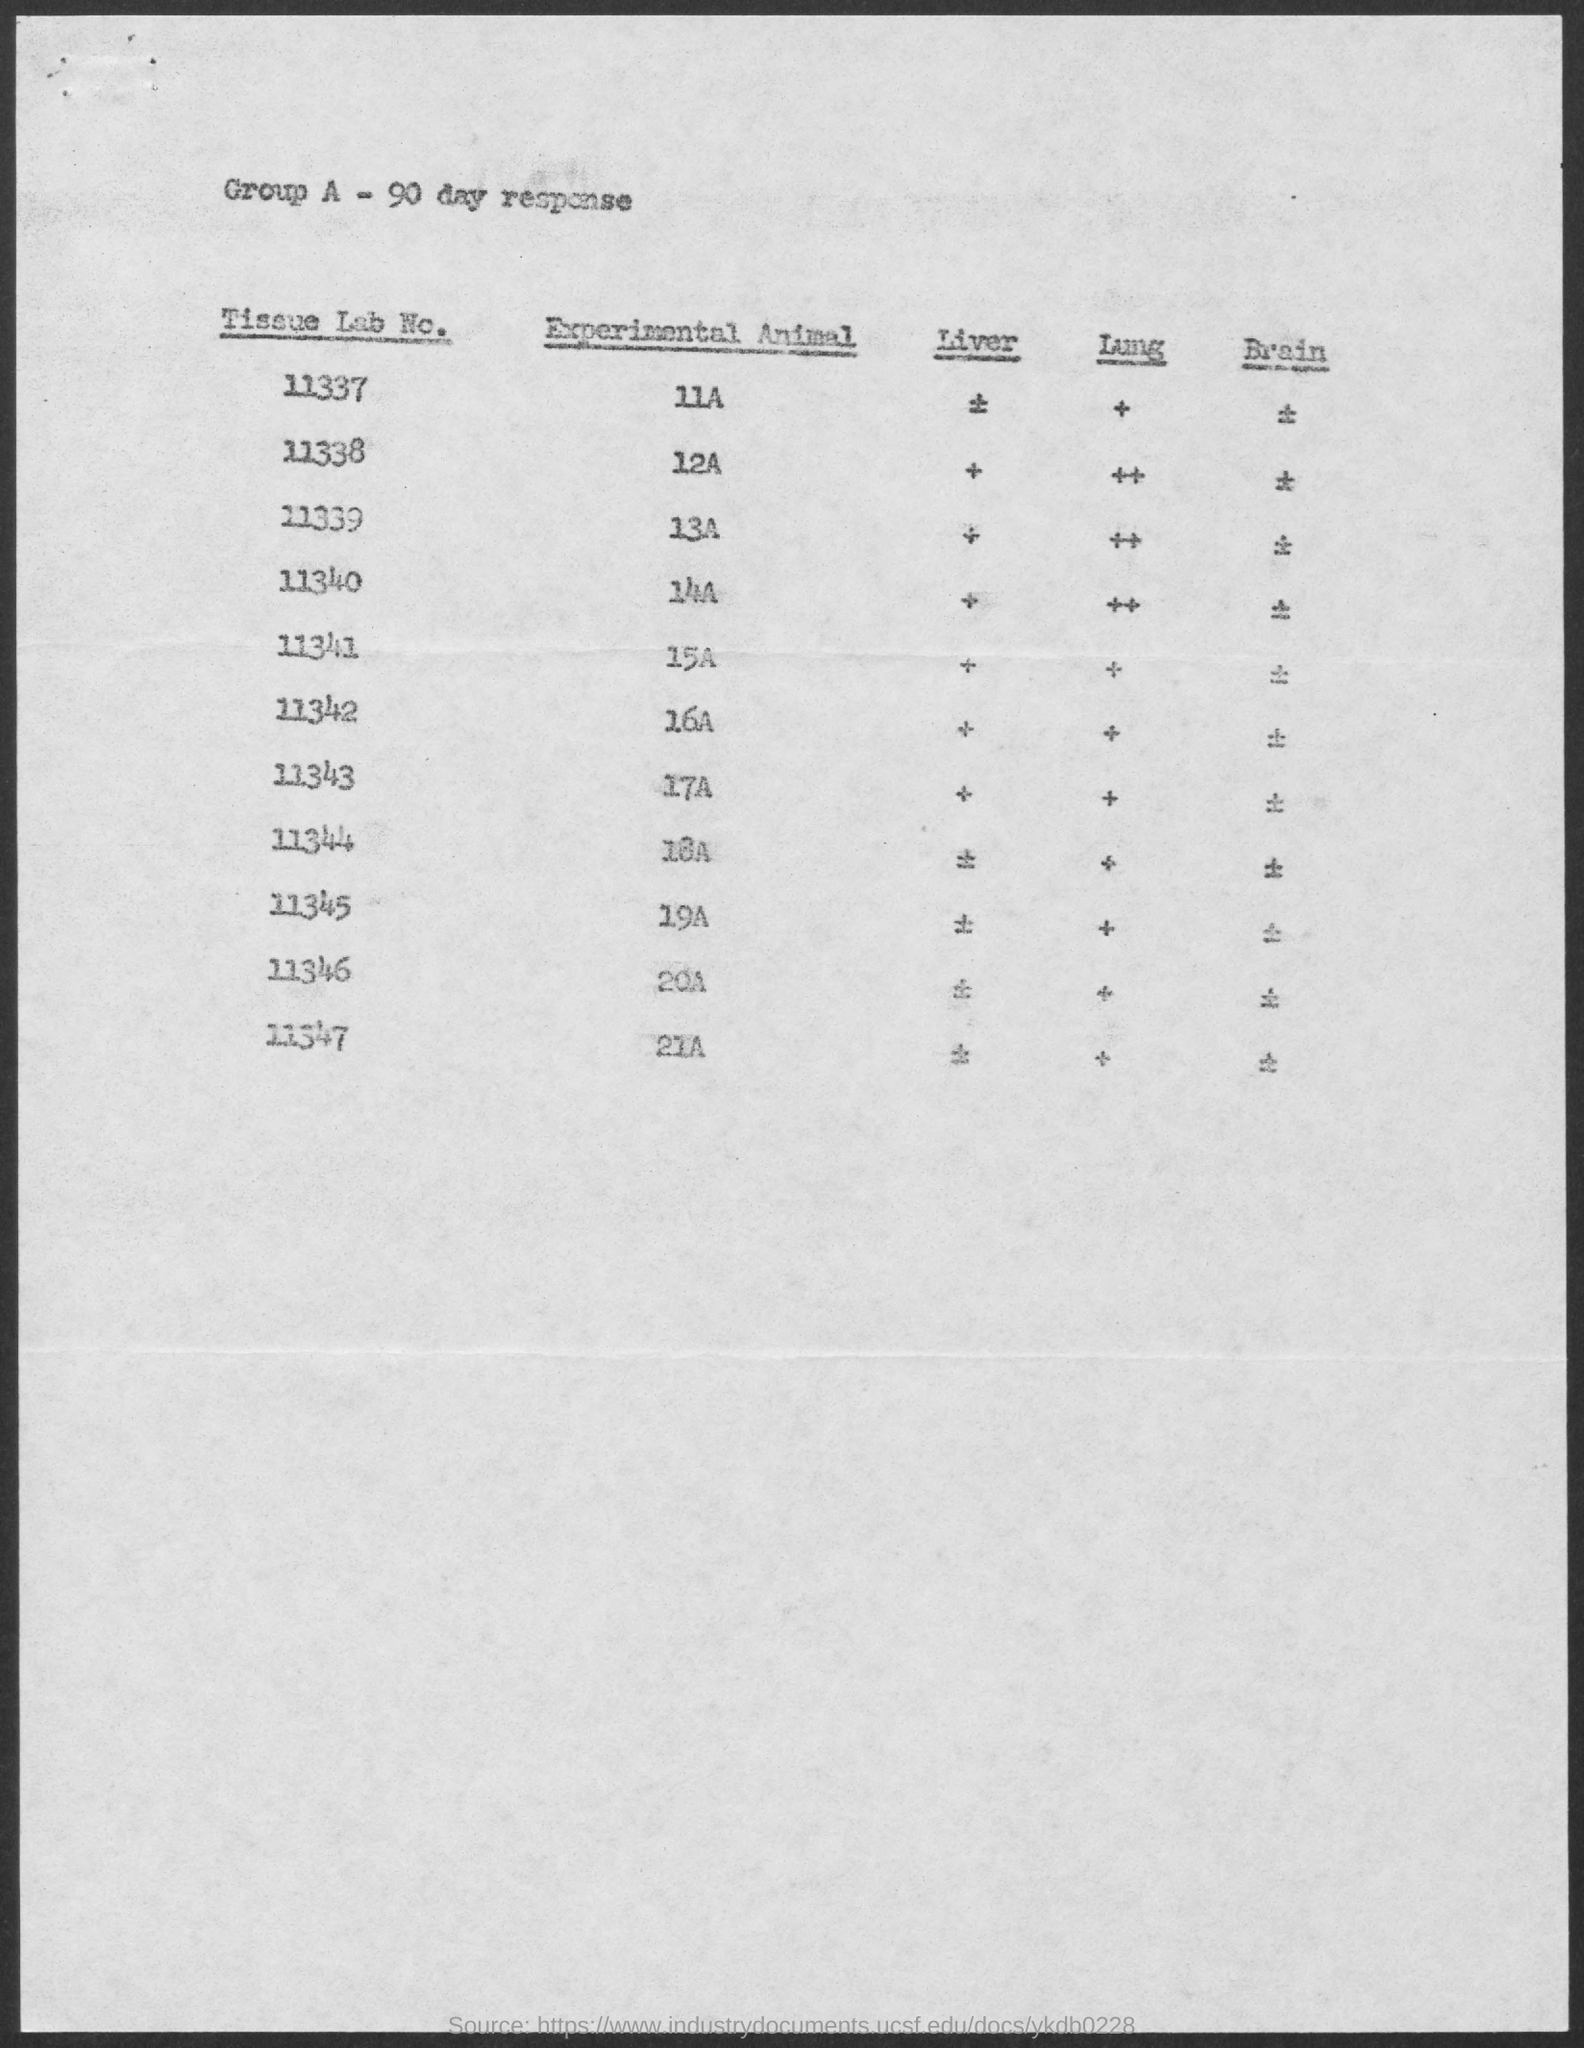Which animal is in tissue lab no.11337 for the experiment?
Offer a terse response. 11A. The experimental animal 12A is in which tissue lab?
Offer a very short reply. 11338. The experimental animal 14A is in which tissue lab?
Provide a short and direct response. 11340. The experimental animal 18A is in which tissue lab?
Make the answer very short. 11344. The experimental animal 21A is in which tissue lab?
Keep it short and to the point. 11347. Which animal is in tissue lab no.11343 for the experiment?
Offer a very short reply. 17A. Which animal is in tissue lab no.11346 for the experiment?
Provide a succinct answer. 20A. Which animal is in tissue lab no.11344 for the experiment?
Offer a terse response. 18A. 